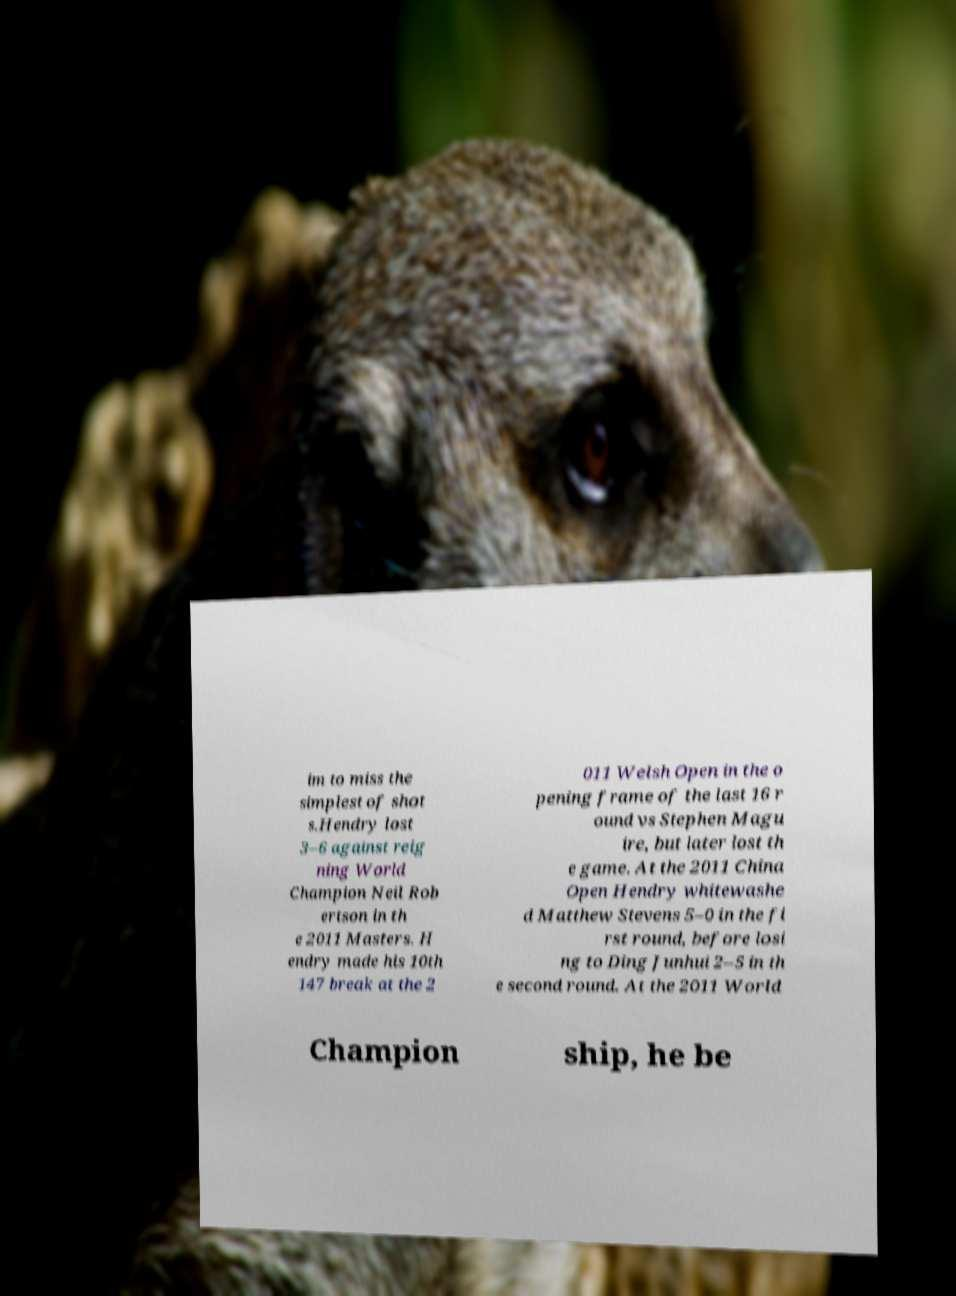Can you accurately transcribe the text from the provided image for me? im to miss the simplest of shot s.Hendry lost 3–6 against reig ning World Champion Neil Rob ertson in th e 2011 Masters. H endry made his 10th 147 break at the 2 011 Welsh Open in the o pening frame of the last 16 r ound vs Stephen Magu ire, but later lost th e game. At the 2011 China Open Hendry whitewashe d Matthew Stevens 5–0 in the fi rst round, before losi ng to Ding Junhui 2–5 in th e second round. At the 2011 World Champion ship, he be 